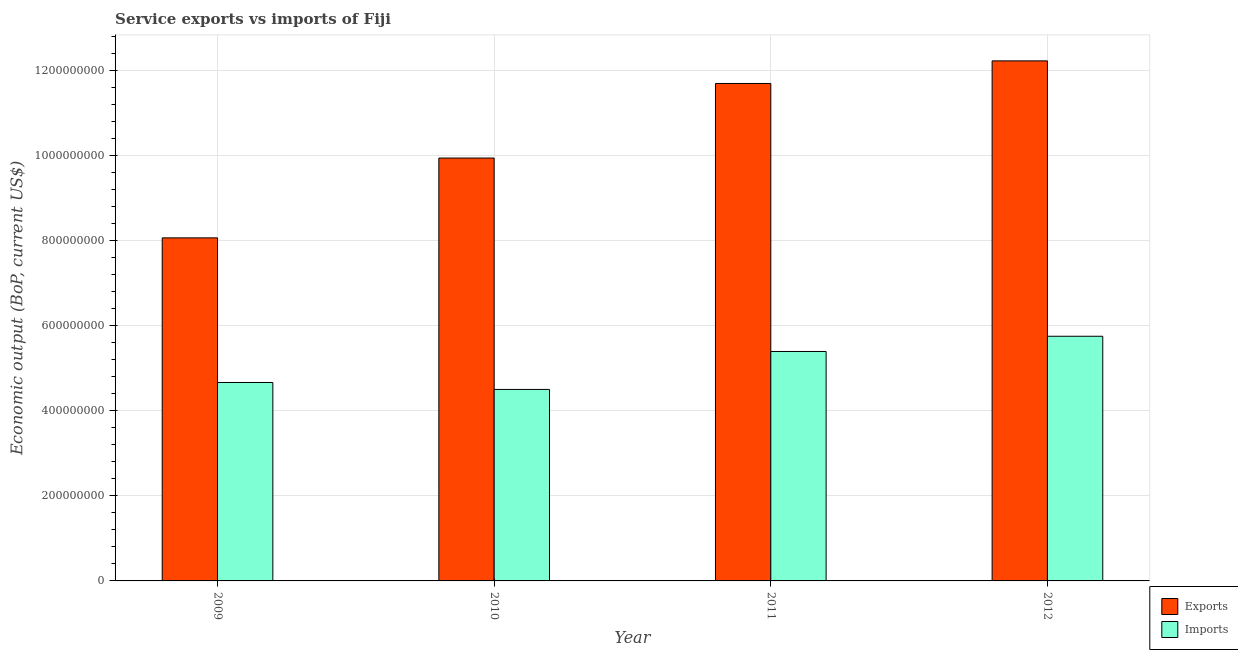How many groups of bars are there?
Provide a short and direct response. 4. What is the label of the 2nd group of bars from the left?
Provide a succinct answer. 2010. What is the amount of service exports in 2010?
Your answer should be compact. 9.93e+08. Across all years, what is the maximum amount of service exports?
Offer a very short reply. 1.22e+09. Across all years, what is the minimum amount of service imports?
Ensure brevity in your answer.  4.50e+08. In which year was the amount of service imports minimum?
Provide a short and direct response. 2010. What is the total amount of service imports in the graph?
Provide a short and direct response. 2.03e+09. What is the difference between the amount of service imports in 2010 and that in 2011?
Ensure brevity in your answer.  -8.92e+07. What is the difference between the amount of service imports in 2011 and the amount of service exports in 2009?
Provide a succinct answer. 7.29e+07. What is the average amount of service exports per year?
Your response must be concise. 1.05e+09. In the year 2010, what is the difference between the amount of service exports and amount of service imports?
Provide a short and direct response. 0. In how many years, is the amount of service exports greater than 360000000 US$?
Ensure brevity in your answer.  4. What is the ratio of the amount of service imports in 2009 to that in 2010?
Provide a succinct answer. 1.04. Is the amount of service exports in 2011 less than that in 2012?
Keep it short and to the point. Yes. What is the difference between the highest and the second highest amount of service exports?
Make the answer very short. 5.31e+07. What is the difference between the highest and the lowest amount of service exports?
Make the answer very short. 4.16e+08. What does the 1st bar from the left in 2011 represents?
Give a very brief answer. Exports. What does the 2nd bar from the right in 2010 represents?
Give a very brief answer. Exports. Are all the bars in the graph horizontal?
Provide a succinct answer. No. How many years are there in the graph?
Make the answer very short. 4. Are the values on the major ticks of Y-axis written in scientific E-notation?
Keep it short and to the point. No. Does the graph contain grids?
Ensure brevity in your answer.  Yes. Where does the legend appear in the graph?
Your answer should be very brief. Bottom right. How are the legend labels stacked?
Your response must be concise. Vertical. What is the title of the graph?
Offer a terse response. Service exports vs imports of Fiji. Does "Central government" appear as one of the legend labels in the graph?
Offer a very short reply. No. What is the label or title of the X-axis?
Offer a terse response. Year. What is the label or title of the Y-axis?
Keep it short and to the point. Economic output (BoP, current US$). What is the Economic output (BoP, current US$) in Exports in 2009?
Your answer should be compact. 8.06e+08. What is the Economic output (BoP, current US$) in Imports in 2009?
Your answer should be compact. 4.66e+08. What is the Economic output (BoP, current US$) in Exports in 2010?
Offer a terse response. 9.93e+08. What is the Economic output (BoP, current US$) of Imports in 2010?
Make the answer very short. 4.50e+08. What is the Economic output (BoP, current US$) of Exports in 2011?
Offer a very short reply. 1.17e+09. What is the Economic output (BoP, current US$) in Imports in 2011?
Ensure brevity in your answer.  5.39e+08. What is the Economic output (BoP, current US$) of Exports in 2012?
Your answer should be compact. 1.22e+09. What is the Economic output (BoP, current US$) in Imports in 2012?
Offer a very short reply. 5.75e+08. Across all years, what is the maximum Economic output (BoP, current US$) of Exports?
Offer a terse response. 1.22e+09. Across all years, what is the maximum Economic output (BoP, current US$) in Imports?
Offer a very short reply. 5.75e+08. Across all years, what is the minimum Economic output (BoP, current US$) in Exports?
Keep it short and to the point. 8.06e+08. Across all years, what is the minimum Economic output (BoP, current US$) in Imports?
Give a very brief answer. 4.50e+08. What is the total Economic output (BoP, current US$) of Exports in the graph?
Provide a succinct answer. 4.19e+09. What is the total Economic output (BoP, current US$) in Imports in the graph?
Offer a terse response. 2.03e+09. What is the difference between the Economic output (BoP, current US$) of Exports in 2009 and that in 2010?
Provide a succinct answer. -1.88e+08. What is the difference between the Economic output (BoP, current US$) in Imports in 2009 and that in 2010?
Your answer should be very brief. 1.63e+07. What is the difference between the Economic output (BoP, current US$) of Exports in 2009 and that in 2011?
Your answer should be compact. -3.63e+08. What is the difference between the Economic output (BoP, current US$) of Imports in 2009 and that in 2011?
Ensure brevity in your answer.  -7.29e+07. What is the difference between the Economic output (BoP, current US$) in Exports in 2009 and that in 2012?
Offer a very short reply. -4.16e+08. What is the difference between the Economic output (BoP, current US$) in Imports in 2009 and that in 2012?
Your answer should be compact. -1.09e+08. What is the difference between the Economic output (BoP, current US$) in Exports in 2010 and that in 2011?
Your answer should be compact. -1.75e+08. What is the difference between the Economic output (BoP, current US$) of Imports in 2010 and that in 2011?
Provide a short and direct response. -8.92e+07. What is the difference between the Economic output (BoP, current US$) in Exports in 2010 and that in 2012?
Ensure brevity in your answer.  -2.28e+08. What is the difference between the Economic output (BoP, current US$) in Imports in 2010 and that in 2012?
Your answer should be very brief. -1.25e+08. What is the difference between the Economic output (BoP, current US$) of Exports in 2011 and that in 2012?
Provide a succinct answer. -5.31e+07. What is the difference between the Economic output (BoP, current US$) of Imports in 2011 and that in 2012?
Your answer should be compact. -3.57e+07. What is the difference between the Economic output (BoP, current US$) in Exports in 2009 and the Economic output (BoP, current US$) in Imports in 2010?
Your answer should be compact. 3.56e+08. What is the difference between the Economic output (BoP, current US$) of Exports in 2009 and the Economic output (BoP, current US$) of Imports in 2011?
Ensure brevity in your answer.  2.67e+08. What is the difference between the Economic output (BoP, current US$) in Exports in 2009 and the Economic output (BoP, current US$) in Imports in 2012?
Offer a very short reply. 2.31e+08. What is the difference between the Economic output (BoP, current US$) in Exports in 2010 and the Economic output (BoP, current US$) in Imports in 2011?
Provide a short and direct response. 4.54e+08. What is the difference between the Economic output (BoP, current US$) of Exports in 2010 and the Economic output (BoP, current US$) of Imports in 2012?
Keep it short and to the point. 4.19e+08. What is the difference between the Economic output (BoP, current US$) of Exports in 2011 and the Economic output (BoP, current US$) of Imports in 2012?
Your answer should be very brief. 5.94e+08. What is the average Economic output (BoP, current US$) in Exports per year?
Keep it short and to the point. 1.05e+09. What is the average Economic output (BoP, current US$) in Imports per year?
Make the answer very short. 5.07e+08. In the year 2009, what is the difference between the Economic output (BoP, current US$) in Exports and Economic output (BoP, current US$) in Imports?
Provide a short and direct response. 3.40e+08. In the year 2010, what is the difference between the Economic output (BoP, current US$) in Exports and Economic output (BoP, current US$) in Imports?
Keep it short and to the point. 5.44e+08. In the year 2011, what is the difference between the Economic output (BoP, current US$) in Exports and Economic output (BoP, current US$) in Imports?
Your answer should be very brief. 6.30e+08. In the year 2012, what is the difference between the Economic output (BoP, current US$) in Exports and Economic output (BoP, current US$) in Imports?
Your answer should be compact. 6.47e+08. What is the ratio of the Economic output (BoP, current US$) in Exports in 2009 to that in 2010?
Your answer should be compact. 0.81. What is the ratio of the Economic output (BoP, current US$) in Imports in 2009 to that in 2010?
Offer a very short reply. 1.04. What is the ratio of the Economic output (BoP, current US$) of Exports in 2009 to that in 2011?
Provide a short and direct response. 0.69. What is the ratio of the Economic output (BoP, current US$) of Imports in 2009 to that in 2011?
Give a very brief answer. 0.86. What is the ratio of the Economic output (BoP, current US$) in Exports in 2009 to that in 2012?
Offer a terse response. 0.66. What is the ratio of the Economic output (BoP, current US$) of Imports in 2009 to that in 2012?
Provide a succinct answer. 0.81. What is the ratio of the Economic output (BoP, current US$) of Exports in 2010 to that in 2011?
Offer a very short reply. 0.85. What is the ratio of the Economic output (BoP, current US$) of Imports in 2010 to that in 2011?
Offer a terse response. 0.83. What is the ratio of the Economic output (BoP, current US$) of Exports in 2010 to that in 2012?
Your answer should be compact. 0.81. What is the ratio of the Economic output (BoP, current US$) of Imports in 2010 to that in 2012?
Give a very brief answer. 0.78. What is the ratio of the Economic output (BoP, current US$) in Exports in 2011 to that in 2012?
Offer a terse response. 0.96. What is the ratio of the Economic output (BoP, current US$) of Imports in 2011 to that in 2012?
Make the answer very short. 0.94. What is the difference between the highest and the second highest Economic output (BoP, current US$) in Exports?
Keep it short and to the point. 5.31e+07. What is the difference between the highest and the second highest Economic output (BoP, current US$) in Imports?
Offer a terse response. 3.57e+07. What is the difference between the highest and the lowest Economic output (BoP, current US$) in Exports?
Give a very brief answer. 4.16e+08. What is the difference between the highest and the lowest Economic output (BoP, current US$) of Imports?
Provide a succinct answer. 1.25e+08. 